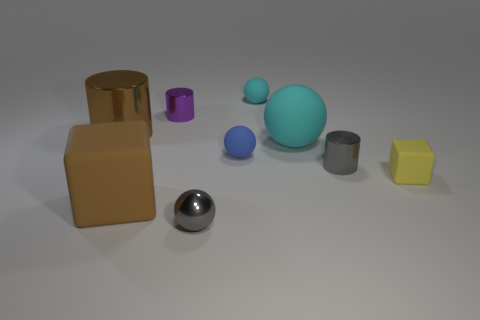Subtract 1 cylinders. How many cylinders are left? 2 Subtract all purple balls. Subtract all gray cylinders. How many balls are left? 4 Add 1 gray cylinders. How many objects exist? 10 Subtract all cylinders. How many objects are left? 6 Add 6 small gray metallic balls. How many small gray metallic balls exist? 7 Subtract 0 green cylinders. How many objects are left? 9 Subtract all big purple matte balls. Subtract all large brown cylinders. How many objects are left? 8 Add 3 large metal cylinders. How many large metal cylinders are left? 4 